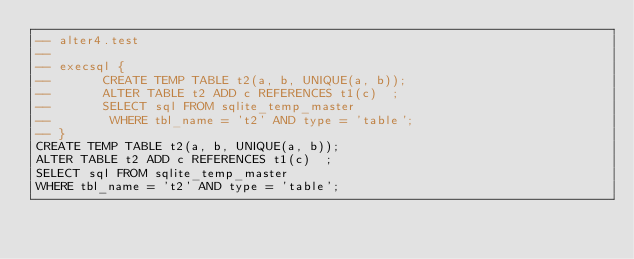Convert code to text. <code><loc_0><loc_0><loc_500><loc_500><_SQL_>-- alter4.test
-- 
-- execsql {
--       CREATE TEMP TABLE t2(a, b, UNIQUE(a, b));
--       ALTER TABLE t2 ADD c REFERENCES t1(c)  ;
--       SELECT sql FROM sqlite_temp_master
--        WHERE tbl_name = 't2' AND type = 'table';
-- }
CREATE TEMP TABLE t2(a, b, UNIQUE(a, b));
ALTER TABLE t2 ADD c REFERENCES t1(c)  ;
SELECT sql FROM sqlite_temp_master
WHERE tbl_name = 't2' AND type = 'table';</code> 